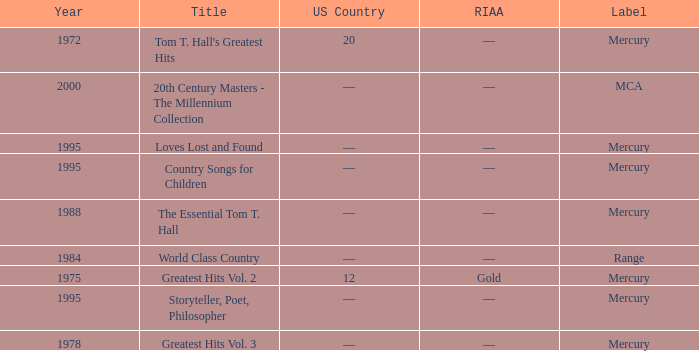Give me the full table as a dictionary. {'header': ['Year', 'Title', 'US Country', 'RIAA', 'Label'], 'rows': [['1972', "Tom T. Hall's Greatest Hits", '20', '—', 'Mercury'], ['2000', '20th Century Masters - The Millennium Collection', '—', '—', 'MCA'], ['1995', 'Loves Lost and Found', '—', '—', 'Mercury'], ['1995', 'Country Songs for Children', '—', '—', 'Mercury'], ['1988', 'The Essential Tom T. Hall', '—', '—', 'Mercury'], ['1984', 'World Class Country', '—', '—', 'Range'], ['1975', 'Greatest Hits Vol. 2', '12', 'Gold', 'Mercury'], ['1995', 'Storyteller, Poet, Philosopher', '—', '—', 'Mercury'], ['1978', 'Greatest Hits Vol. 3', '—', '—', 'Mercury']]} What is the highest year for the title, "loves lost and found"? 1995.0. 